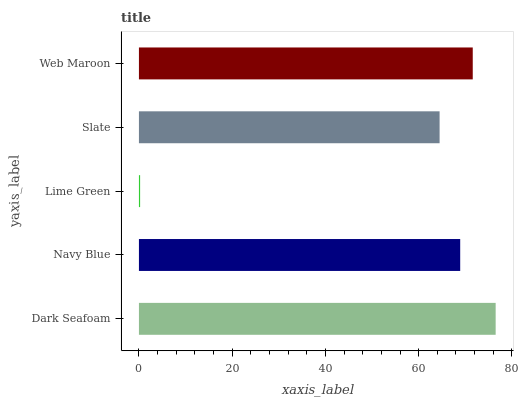Is Lime Green the minimum?
Answer yes or no. Yes. Is Dark Seafoam the maximum?
Answer yes or no. Yes. Is Navy Blue the minimum?
Answer yes or no. No. Is Navy Blue the maximum?
Answer yes or no. No. Is Dark Seafoam greater than Navy Blue?
Answer yes or no. Yes. Is Navy Blue less than Dark Seafoam?
Answer yes or no. Yes. Is Navy Blue greater than Dark Seafoam?
Answer yes or no. No. Is Dark Seafoam less than Navy Blue?
Answer yes or no. No. Is Navy Blue the high median?
Answer yes or no. Yes. Is Navy Blue the low median?
Answer yes or no. Yes. Is Slate the high median?
Answer yes or no. No. Is Lime Green the low median?
Answer yes or no. No. 